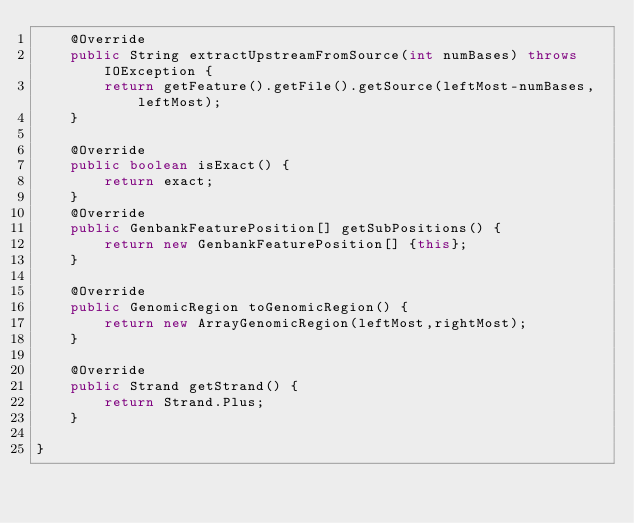<code> <loc_0><loc_0><loc_500><loc_500><_Java_>	@Override
	public String extractUpstreamFromSource(int numBases) throws IOException {
		return getFeature().getFile().getSource(leftMost-numBases,leftMost);
	}
	
	@Override
	public boolean isExact() {
		return exact;
	}
	@Override
	public GenbankFeaturePosition[] getSubPositions() {
		return new GenbankFeaturePosition[] {this};
	}
	
	@Override
	public GenomicRegion toGenomicRegion() {
		return new ArrayGenomicRegion(leftMost,rightMost);
	}
	
	@Override
	public Strand getStrand() {
		return Strand.Plus;
	}
	
}
</code> 